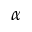<formula> <loc_0><loc_0><loc_500><loc_500>\alpha</formula> 